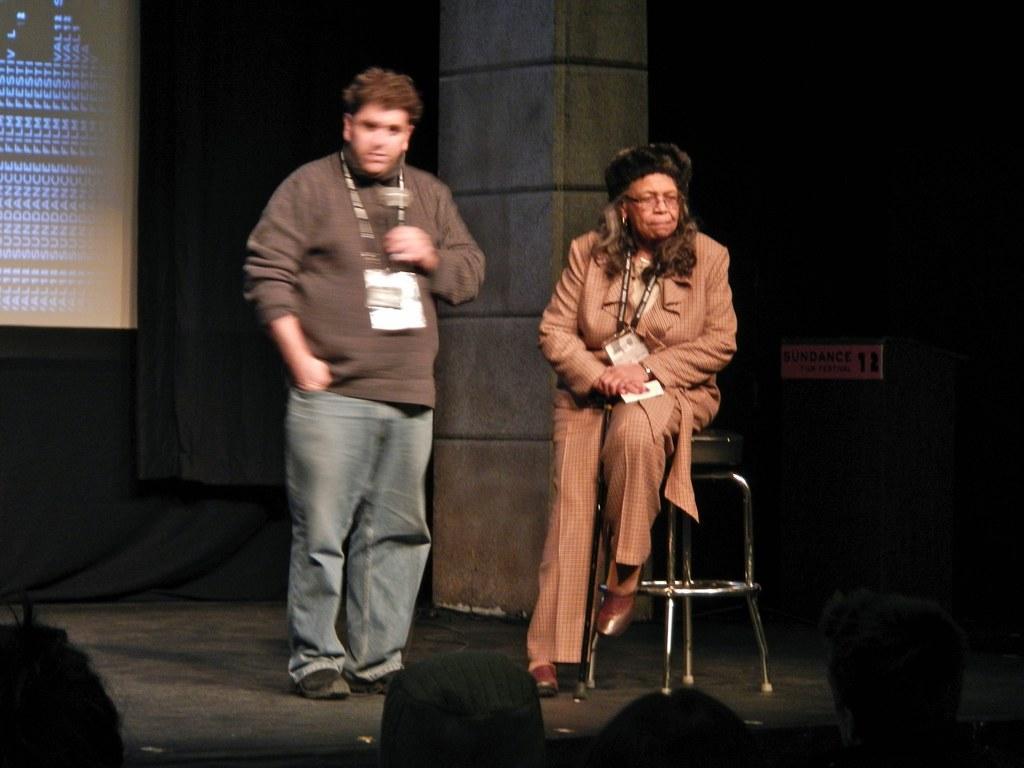Describe this image in one or two sentences. In this picture I can a person standing on the left side. I can see a person sitting on the table. I can see the pillar. 